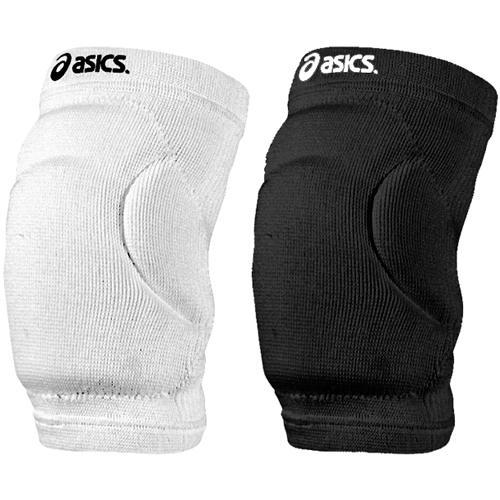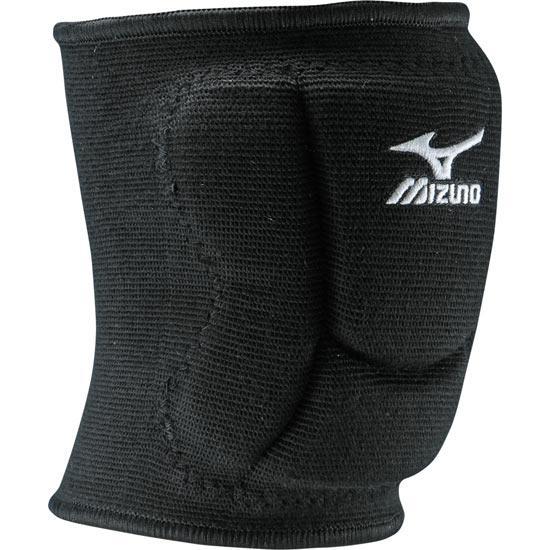The first image is the image on the left, the second image is the image on the right. Given the left and right images, does the statement "One of the paired images contains one black brace and one white brace." hold true? Answer yes or no. Yes. 